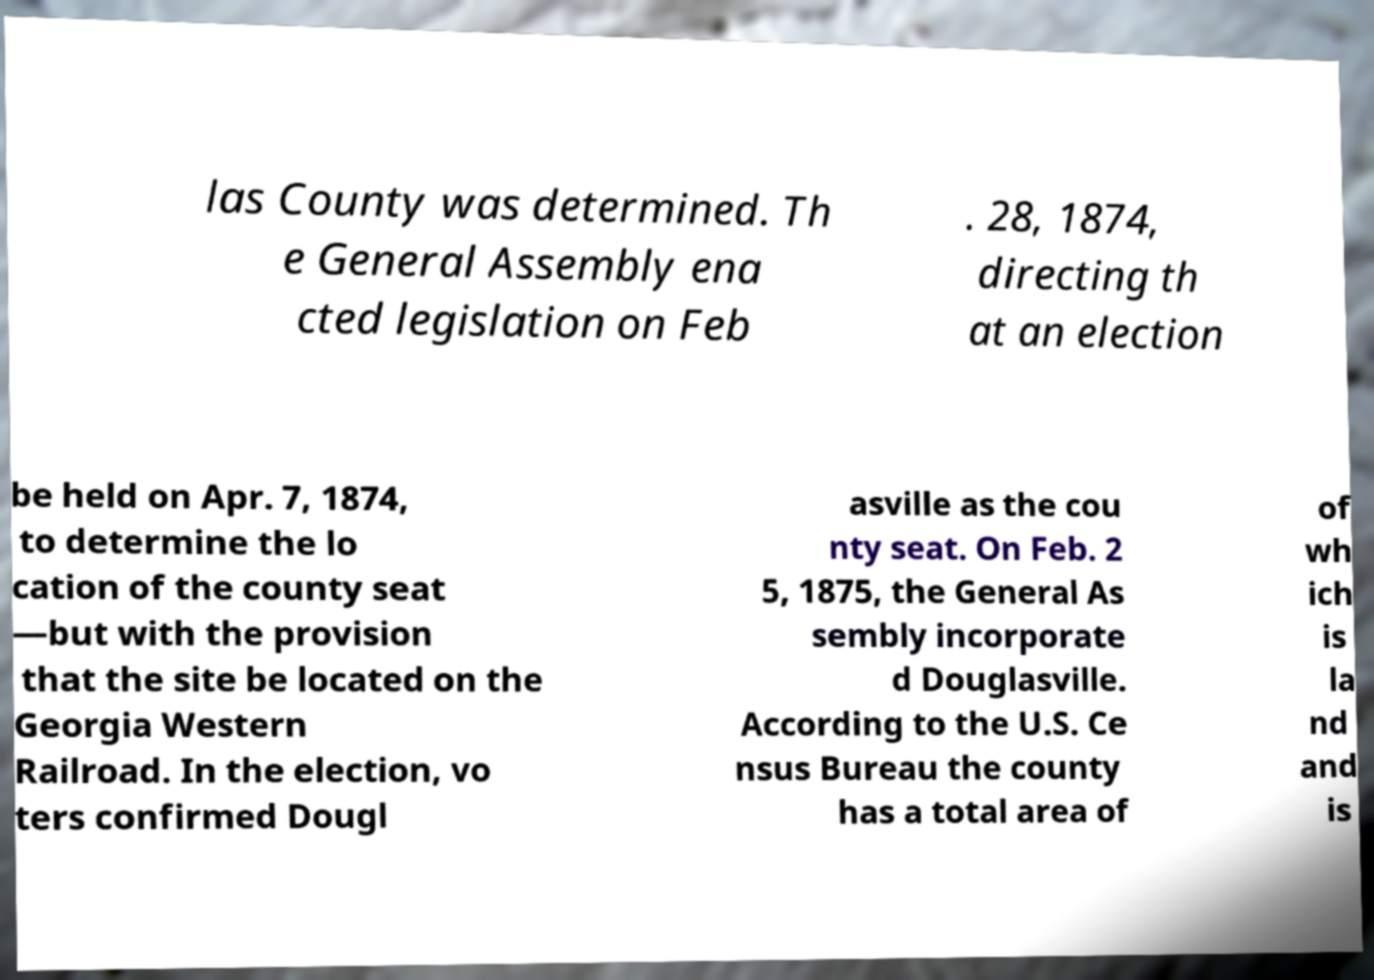For documentation purposes, I need the text within this image transcribed. Could you provide that? las County was determined. Th e General Assembly ena cted legislation on Feb . 28, 1874, directing th at an election be held on Apr. 7, 1874, to determine the lo cation of the county seat —but with the provision that the site be located on the Georgia Western Railroad. In the election, vo ters confirmed Dougl asville as the cou nty seat. On Feb. 2 5, 1875, the General As sembly incorporate d Douglasville. According to the U.S. Ce nsus Bureau the county has a total area of of wh ich is la nd and is 